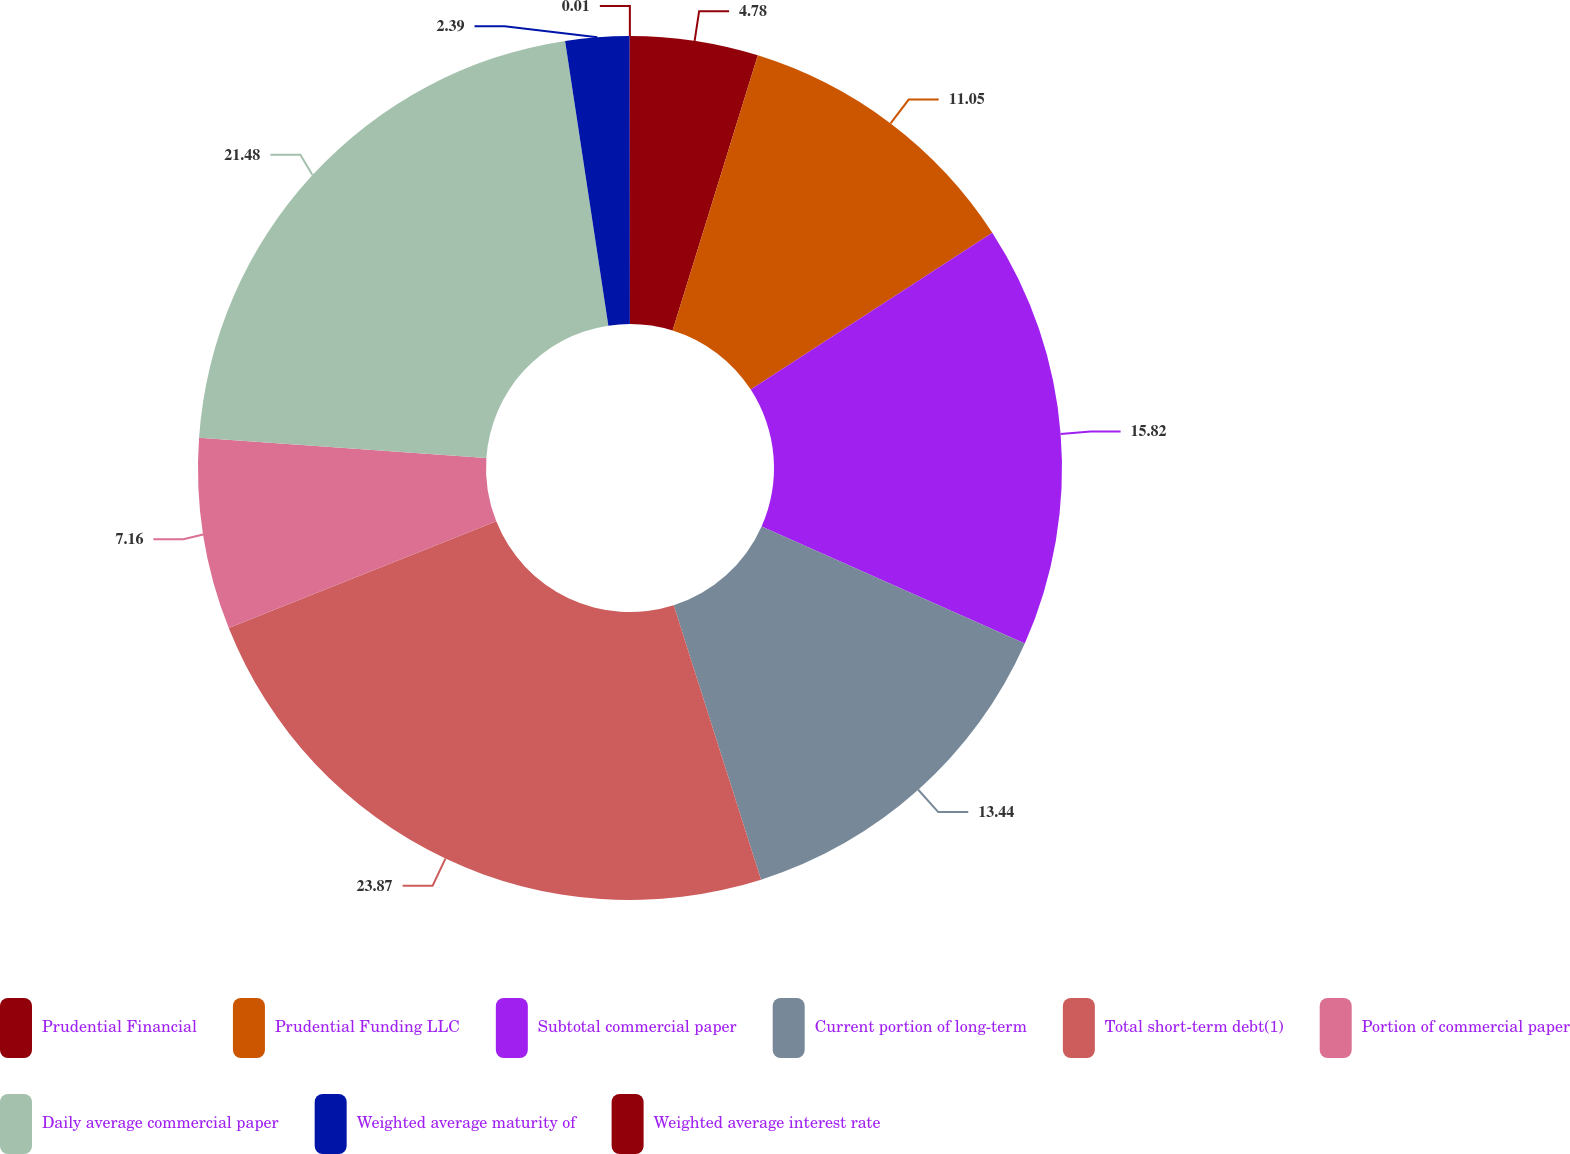Convert chart to OTSL. <chart><loc_0><loc_0><loc_500><loc_500><pie_chart><fcel>Prudential Financial<fcel>Prudential Funding LLC<fcel>Subtotal commercial paper<fcel>Current portion of long-term<fcel>Total short-term debt(1)<fcel>Portion of commercial paper<fcel>Daily average commercial paper<fcel>Weighted average maturity of<fcel>Weighted average interest rate<nl><fcel>4.78%<fcel>11.05%<fcel>15.82%<fcel>13.44%<fcel>23.86%<fcel>7.16%<fcel>21.48%<fcel>2.39%<fcel>0.01%<nl></chart> 